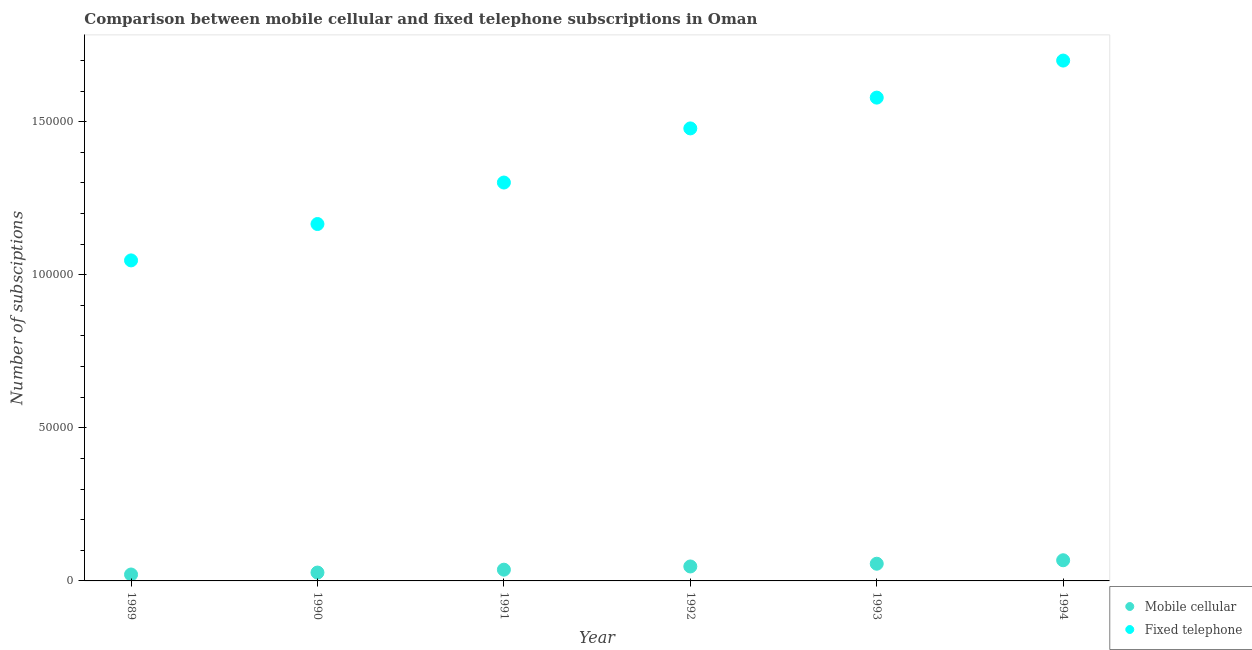How many different coloured dotlines are there?
Your response must be concise. 2. What is the number of fixed telephone subscriptions in 1994?
Offer a very short reply. 1.70e+05. Across all years, what is the maximum number of mobile cellular subscriptions?
Offer a terse response. 6751. Across all years, what is the minimum number of mobile cellular subscriptions?
Your response must be concise. 2098. What is the total number of fixed telephone subscriptions in the graph?
Keep it short and to the point. 8.27e+05. What is the difference between the number of mobile cellular subscriptions in 1989 and that in 1994?
Keep it short and to the point. -4653. What is the difference between the number of mobile cellular subscriptions in 1989 and the number of fixed telephone subscriptions in 1993?
Give a very brief answer. -1.56e+05. What is the average number of mobile cellular subscriptions per year?
Offer a terse response. 4264.67. In the year 1991, what is the difference between the number of mobile cellular subscriptions and number of fixed telephone subscriptions?
Ensure brevity in your answer.  -1.26e+05. In how many years, is the number of fixed telephone subscriptions greater than 90000?
Your answer should be compact. 6. What is the ratio of the number of fixed telephone subscriptions in 1991 to that in 1992?
Provide a short and direct response. 0.88. Is the difference between the number of mobile cellular subscriptions in 1991 and 1992 greater than the difference between the number of fixed telephone subscriptions in 1991 and 1992?
Ensure brevity in your answer.  Yes. What is the difference between the highest and the second highest number of mobile cellular subscriptions?
Your answer should be compact. 1135. What is the difference between the highest and the lowest number of mobile cellular subscriptions?
Make the answer very short. 4653. Is the sum of the number of mobile cellular subscriptions in 1989 and 1990 greater than the maximum number of fixed telephone subscriptions across all years?
Ensure brevity in your answer.  No. Is the number of mobile cellular subscriptions strictly less than the number of fixed telephone subscriptions over the years?
Keep it short and to the point. Yes. How many dotlines are there?
Your answer should be very brief. 2. How many years are there in the graph?
Your answer should be compact. 6. What is the difference between two consecutive major ticks on the Y-axis?
Your answer should be very brief. 5.00e+04. Are the values on the major ticks of Y-axis written in scientific E-notation?
Offer a very short reply. No. Does the graph contain grids?
Give a very brief answer. No. Where does the legend appear in the graph?
Provide a short and direct response. Bottom right. How many legend labels are there?
Ensure brevity in your answer.  2. What is the title of the graph?
Make the answer very short. Comparison between mobile cellular and fixed telephone subscriptions in Oman. Does "All education staff compensation" appear as one of the legend labels in the graph?
Keep it short and to the point. No. What is the label or title of the Y-axis?
Offer a very short reply. Number of subsciptions. What is the Number of subsciptions of Mobile cellular in 1989?
Give a very brief answer. 2098. What is the Number of subsciptions in Fixed telephone in 1989?
Offer a very short reply. 1.05e+05. What is the Number of subsciptions in Mobile cellular in 1990?
Your answer should be compact. 2730. What is the Number of subsciptions in Fixed telephone in 1990?
Ensure brevity in your answer.  1.17e+05. What is the Number of subsciptions in Mobile cellular in 1991?
Ensure brevity in your answer.  3672. What is the Number of subsciptions in Fixed telephone in 1991?
Your answer should be compact. 1.30e+05. What is the Number of subsciptions of Mobile cellular in 1992?
Your answer should be compact. 4721. What is the Number of subsciptions of Fixed telephone in 1992?
Provide a short and direct response. 1.48e+05. What is the Number of subsciptions in Mobile cellular in 1993?
Offer a terse response. 5616. What is the Number of subsciptions of Fixed telephone in 1993?
Provide a short and direct response. 1.58e+05. What is the Number of subsciptions of Mobile cellular in 1994?
Your answer should be very brief. 6751. What is the Number of subsciptions of Fixed telephone in 1994?
Your response must be concise. 1.70e+05. Across all years, what is the maximum Number of subsciptions of Mobile cellular?
Offer a terse response. 6751. Across all years, what is the maximum Number of subsciptions in Fixed telephone?
Provide a succinct answer. 1.70e+05. Across all years, what is the minimum Number of subsciptions in Mobile cellular?
Ensure brevity in your answer.  2098. Across all years, what is the minimum Number of subsciptions in Fixed telephone?
Provide a succinct answer. 1.05e+05. What is the total Number of subsciptions in Mobile cellular in the graph?
Provide a short and direct response. 2.56e+04. What is the total Number of subsciptions of Fixed telephone in the graph?
Your answer should be compact. 8.27e+05. What is the difference between the Number of subsciptions in Mobile cellular in 1989 and that in 1990?
Ensure brevity in your answer.  -632. What is the difference between the Number of subsciptions of Fixed telephone in 1989 and that in 1990?
Provide a succinct answer. -1.19e+04. What is the difference between the Number of subsciptions of Mobile cellular in 1989 and that in 1991?
Give a very brief answer. -1574. What is the difference between the Number of subsciptions in Fixed telephone in 1989 and that in 1991?
Provide a short and direct response. -2.54e+04. What is the difference between the Number of subsciptions of Mobile cellular in 1989 and that in 1992?
Give a very brief answer. -2623. What is the difference between the Number of subsciptions of Fixed telephone in 1989 and that in 1992?
Your answer should be compact. -4.31e+04. What is the difference between the Number of subsciptions in Mobile cellular in 1989 and that in 1993?
Provide a succinct answer. -3518. What is the difference between the Number of subsciptions in Fixed telephone in 1989 and that in 1993?
Offer a terse response. -5.32e+04. What is the difference between the Number of subsciptions in Mobile cellular in 1989 and that in 1994?
Provide a short and direct response. -4653. What is the difference between the Number of subsciptions in Fixed telephone in 1989 and that in 1994?
Offer a terse response. -6.53e+04. What is the difference between the Number of subsciptions in Mobile cellular in 1990 and that in 1991?
Offer a very short reply. -942. What is the difference between the Number of subsciptions of Fixed telephone in 1990 and that in 1991?
Offer a very short reply. -1.35e+04. What is the difference between the Number of subsciptions in Mobile cellular in 1990 and that in 1992?
Ensure brevity in your answer.  -1991. What is the difference between the Number of subsciptions of Fixed telephone in 1990 and that in 1992?
Your response must be concise. -3.12e+04. What is the difference between the Number of subsciptions in Mobile cellular in 1990 and that in 1993?
Provide a short and direct response. -2886. What is the difference between the Number of subsciptions in Fixed telephone in 1990 and that in 1993?
Offer a very short reply. -4.13e+04. What is the difference between the Number of subsciptions of Mobile cellular in 1990 and that in 1994?
Provide a succinct answer. -4021. What is the difference between the Number of subsciptions of Fixed telephone in 1990 and that in 1994?
Provide a succinct answer. -5.34e+04. What is the difference between the Number of subsciptions of Mobile cellular in 1991 and that in 1992?
Ensure brevity in your answer.  -1049. What is the difference between the Number of subsciptions of Fixed telephone in 1991 and that in 1992?
Offer a terse response. -1.77e+04. What is the difference between the Number of subsciptions in Mobile cellular in 1991 and that in 1993?
Provide a short and direct response. -1944. What is the difference between the Number of subsciptions in Fixed telephone in 1991 and that in 1993?
Your answer should be compact. -2.77e+04. What is the difference between the Number of subsciptions in Mobile cellular in 1991 and that in 1994?
Provide a short and direct response. -3079. What is the difference between the Number of subsciptions of Fixed telephone in 1991 and that in 1994?
Keep it short and to the point. -3.98e+04. What is the difference between the Number of subsciptions in Mobile cellular in 1992 and that in 1993?
Your answer should be compact. -895. What is the difference between the Number of subsciptions in Fixed telephone in 1992 and that in 1993?
Provide a short and direct response. -1.01e+04. What is the difference between the Number of subsciptions of Mobile cellular in 1992 and that in 1994?
Your answer should be compact. -2030. What is the difference between the Number of subsciptions of Fixed telephone in 1992 and that in 1994?
Offer a very short reply. -2.22e+04. What is the difference between the Number of subsciptions of Mobile cellular in 1993 and that in 1994?
Your response must be concise. -1135. What is the difference between the Number of subsciptions in Fixed telephone in 1993 and that in 1994?
Provide a short and direct response. -1.21e+04. What is the difference between the Number of subsciptions in Mobile cellular in 1989 and the Number of subsciptions in Fixed telephone in 1990?
Offer a terse response. -1.14e+05. What is the difference between the Number of subsciptions of Mobile cellular in 1989 and the Number of subsciptions of Fixed telephone in 1991?
Your answer should be compact. -1.28e+05. What is the difference between the Number of subsciptions of Mobile cellular in 1989 and the Number of subsciptions of Fixed telephone in 1992?
Your answer should be very brief. -1.46e+05. What is the difference between the Number of subsciptions in Mobile cellular in 1989 and the Number of subsciptions in Fixed telephone in 1993?
Your response must be concise. -1.56e+05. What is the difference between the Number of subsciptions of Mobile cellular in 1989 and the Number of subsciptions of Fixed telephone in 1994?
Provide a short and direct response. -1.68e+05. What is the difference between the Number of subsciptions of Mobile cellular in 1990 and the Number of subsciptions of Fixed telephone in 1991?
Ensure brevity in your answer.  -1.27e+05. What is the difference between the Number of subsciptions of Mobile cellular in 1990 and the Number of subsciptions of Fixed telephone in 1992?
Provide a short and direct response. -1.45e+05. What is the difference between the Number of subsciptions in Mobile cellular in 1990 and the Number of subsciptions in Fixed telephone in 1993?
Offer a very short reply. -1.55e+05. What is the difference between the Number of subsciptions of Mobile cellular in 1990 and the Number of subsciptions of Fixed telephone in 1994?
Ensure brevity in your answer.  -1.67e+05. What is the difference between the Number of subsciptions of Mobile cellular in 1991 and the Number of subsciptions of Fixed telephone in 1992?
Your response must be concise. -1.44e+05. What is the difference between the Number of subsciptions of Mobile cellular in 1991 and the Number of subsciptions of Fixed telephone in 1993?
Give a very brief answer. -1.54e+05. What is the difference between the Number of subsciptions of Mobile cellular in 1991 and the Number of subsciptions of Fixed telephone in 1994?
Keep it short and to the point. -1.66e+05. What is the difference between the Number of subsciptions of Mobile cellular in 1992 and the Number of subsciptions of Fixed telephone in 1993?
Offer a terse response. -1.53e+05. What is the difference between the Number of subsciptions of Mobile cellular in 1992 and the Number of subsciptions of Fixed telephone in 1994?
Keep it short and to the point. -1.65e+05. What is the difference between the Number of subsciptions of Mobile cellular in 1993 and the Number of subsciptions of Fixed telephone in 1994?
Make the answer very short. -1.64e+05. What is the average Number of subsciptions in Mobile cellular per year?
Provide a short and direct response. 4264.67. What is the average Number of subsciptions of Fixed telephone per year?
Give a very brief answer. 1.38e+05. In the year 1989, what is the difference between the Number of subsciptions in Mobile cellular and Number of subsciptions in Fixed telephone?
Your answer should be very brief. -1.03e+05. In the year 1990, what is the difference between the Number of subsciptions of Mobile cellular and Number of subsciptions of Fixed telephone?
Offer a terse response. -1.14e+05. In the year 1991, what is the difference between the Number of subsciptions in Mobile cellular and Number of subsciptions in Fixed telephone?
Give a very brief answer. -1.26e+05. In the year 1992, what is the difference between the Number of subsciptions of Mobile cellular and Number of subsciptions of Fixed telephone?
Your response must be concise. -1.43e+05. In the year 1993, what is the difference between the Number of subsciptions in Mobile cellular and Number of subsciptions in Fixed telephone?
Your answer should be very brief. -1.52e+05. In the year 1994, what is the difference between the Number of subsciptions in Mobile cellular and Number of subsciptions in Fixed telephone?
Provide a short and direct response. -1.63e+05. What is the ratio of the Number of subsciptions of Mobile cellular in 1989 to that in 1990?
Your answer should be compact. 0.77. What is the ratio of the Number of subsciptions of Fixed telephone in 1989 to that in 1990?
Keep it short and to the point. 0.9. What is the ratio of the Number of subsciptions of Mobile cellular in 1989 to that in 1991?
Your answer should be very brief. 0.57. What is the ratio of the Number of subsciptions of Fixed telephone in 1989 to that in 1991?
Provide a short and direct response. 0.8. What is the ratio of the Number of subsciptions in Mobile cellular in 1989 to that in 1992?
Make the answer very short. 0.44. What is the ratio of the Number of subsciptions in Fixed telephone in 1989 to that in 1992?
Keep it short and to the point. 0.71. What is the ratio of the Number of subsciptions of Mobile cellular in 1989 to that in 1993?
Your answer should be very brief. 0.37. What is the ratio of the Number of subsciptions of Fixed telephone in 1989 to that in 1993?
Ensure brevity in your answer.  0.66. What is the ratio of the Number of subsciptions of Mobile cellular in 1989 to that in 1994?
Ensure brevity in your answer.  0.31. What is the ratio of the Number of subsciptions of Fixed telephone in 1989 to that in 1994?
Offer a very short reply. 0.62. What is the ratio of the Number of subsciptions in Mobile cellular in 1990 to that in 1991?
Make the answer very short. 0.74. What is the ratio of the Number of subsciptions in Fixed telephone in 1990 to that in 1991?
Your answer should be very brief. 0.9. What is the ratio of the Number of subsciptions in Mobile cellular in 1990 to that in 1992?
Offer a very short reply. 0.58. What is the ratio of the Number of subsciptions of Fixed telephone in 1990 to that in 1992?
Your answer should be compact. 0.79. What is the ratio of the Number of subsciptions in Mobile cellular in 1990 to that in 1993?
Ensure brevity in your answer.  0.49. What is the ratio of the Number of subsciptions in Fixed telephone in 1990 to that in 1993?
Offer a terse response. 0.74. What is the ratio of the Number of subsciptions in Mobile cellular in 1990 to that in 1994?
Make the answer very short. 0.4. What is the ratio of the Number of subsciptions in Fixed telephone in 1990 to that in 1994?
Provide a succinct answer. 0.69. What is the ratio of the Number of subsciptions in Fixed telephone in 1991 to that in 1992?
Provide a succinct answer. 0.88. What is the ratio of the Number of subsciptions of Mobile cellular in 1991 to that in 1993?
Keep it short and to the point. 0.65. What is the ratio of the Number of subsciptions in Fixed telephone in 1991 to that in 1993?
Provide a short and direct response. 0.82. What is the ratio of the Number of subsciptions of Mobile cellular in 1991 to that in 1994?
Provide a succinct answer. 0.54. What is the ratio of the Number of subsciptions in Fixed telephone in 1991 to that in 1994?
Keep it short and to the point. 0.77. What is the ratio of the Number of subsciptions of Mobile cellular in 1992 to that in 1993?
Offer a very short reply. 0.84. What is the ratio of the Number of subsciptions in Fixed telephone in 1992 to that in 1993?
Give a very brief answer. 0.94. What is the ratio of the Number of subsciptions in Mobile cellular in 1992 to that in 1994?
Offer a terse response. 0.7. What is the ratio of the Number of subsciptions in Fixed telephone in 1992 to that in 1994?
Your response must be concise. 0.87. What is the ratio of the Number of subsciptions of Mobile cellular in 1993 to that in 1994?
Your answer should be very brief. 0.83. What is the ratio of the Number of subsciptions in Fixed telephone in 1993 to that in 1994?
Your response must be concise. 0.93. What is the difference between the highest and the second highest Number of subsciptions in Mobile cellular?
Make the answer very short. 1135. What is the difference between the highest and the second highest Number of subsciptions of Fixed telephone?
Make the answer very short. 1.21e+04. What is the difference between the highest and the lowest Number of subsciptions in Mobile cellular?
Ensure brevity in your answer.  4653. What is the difference between the highest and the lowest Number of subsciptions of Fixed telephone?
Provide a short and direct response. 6.53e+04. 